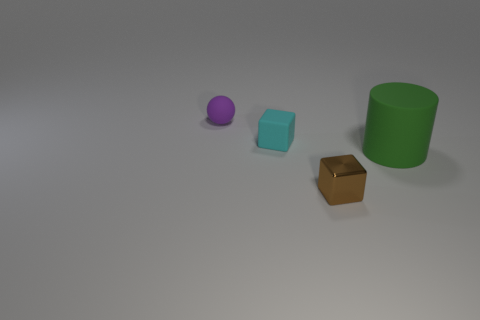Add 3 tiny green rubber balls. How many objects exist? 7 Subtract all balls. How many objects are left? 3 Subtract all large matte cylinders. Subtract all small cyan rubber blocks. How many objects are left? 2 Add 2 tiny brown shiny things. How many tiny brown shiny things are left? 3 Add 2 tiny cyan metallic cylinders. How many tiny cyan metallic cylinders exist? 2 Subtract 0 cyan cylinders. How many objects are left? 4 